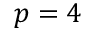<formula> <loc_0><loc_0><loc_500><loc_500>p = 4</formula> 